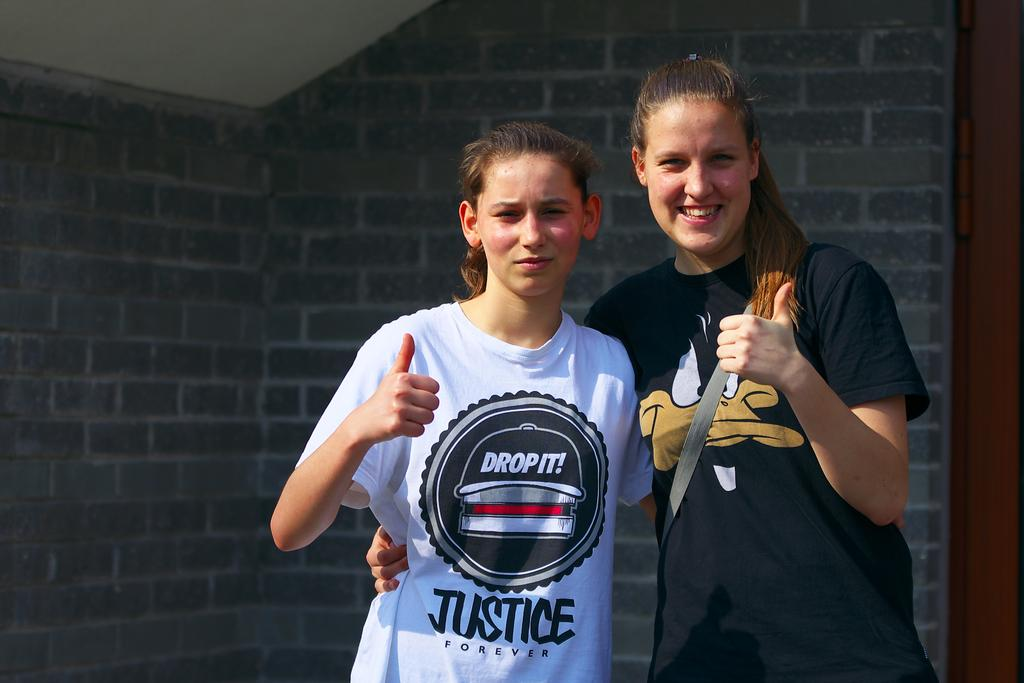<image>
Relay a brief, clear account of the picture shown. A girl has the word justice on her shirt. 